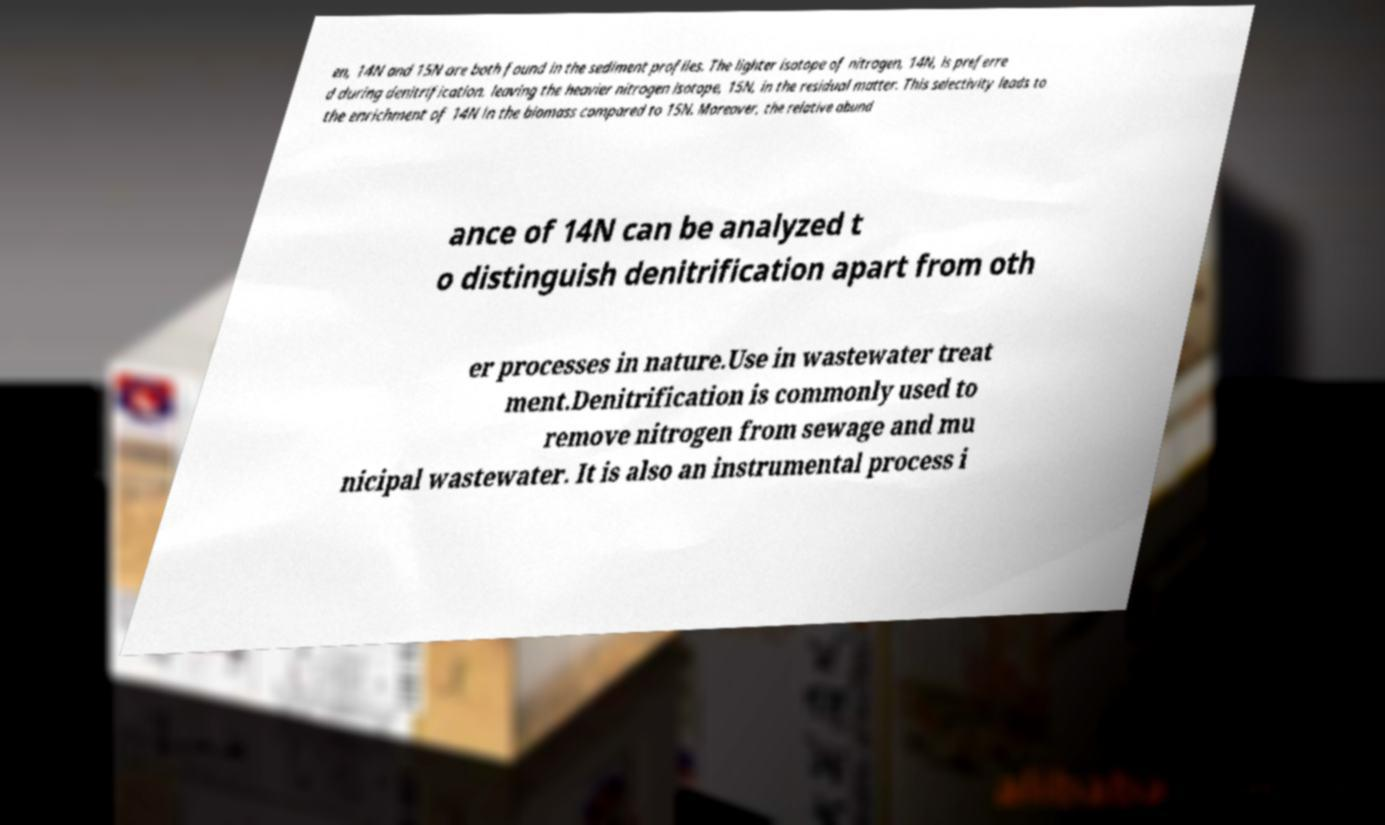Could you extract and type out the text from this image? en, 14N and 15N are both found in the sediment profiles. The lighter isotope of nitrogen, 14N, is preferre d during denitrification, leaving the heavier nitrogen isotope, 15N, in the residual matter. This selectivity leads to the enrichment of 14N in the biomass compared to 15N. Moreover, the relative abund ance of 14N can be analyzed t o distinguish denitrification apart from oth er processes in nature.Use in wastewater treat ment.Denitrification is commonly used to remove nitrogen from sewage and mu nicipal wastewater. It is also an instrumental process i 